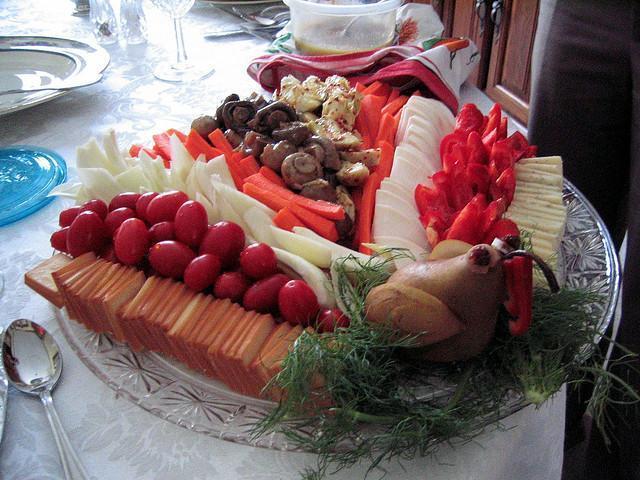How many bars is the horse jumping over?
Give a very brief answer. 0. 